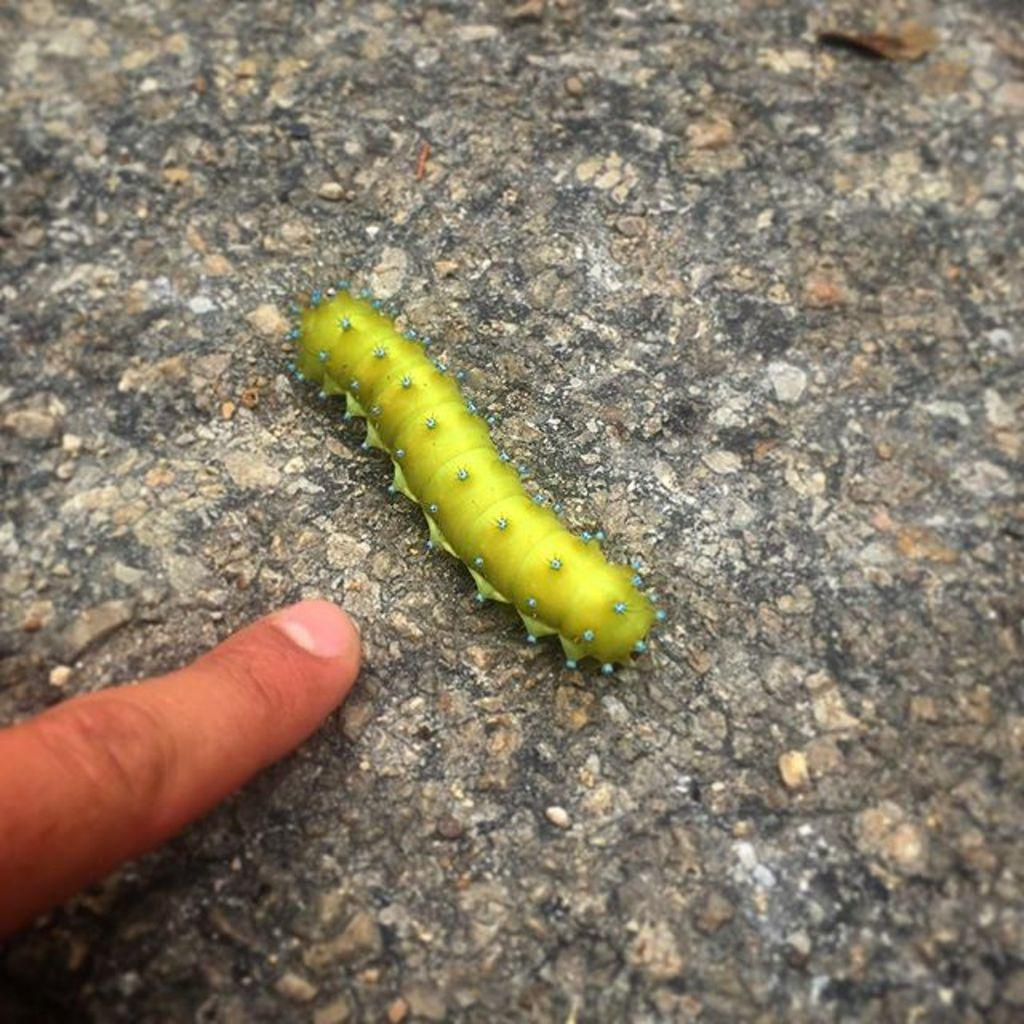What type of insect is in the image? There is a green color insect in the image, which looks like a caterpillar. Where is the insect located in relation to the human hand? The insect is not in contact with the human hand in the image. On which side of the image is the human hand? The human hand is on the left side of the image. What year is depicted in the image? The image does not depict a specific year; it features a green caterpillar and a human hand. What order of insects does the caterpillar belong to? The image does not provide enough information to determine the order of the caterpillar. 